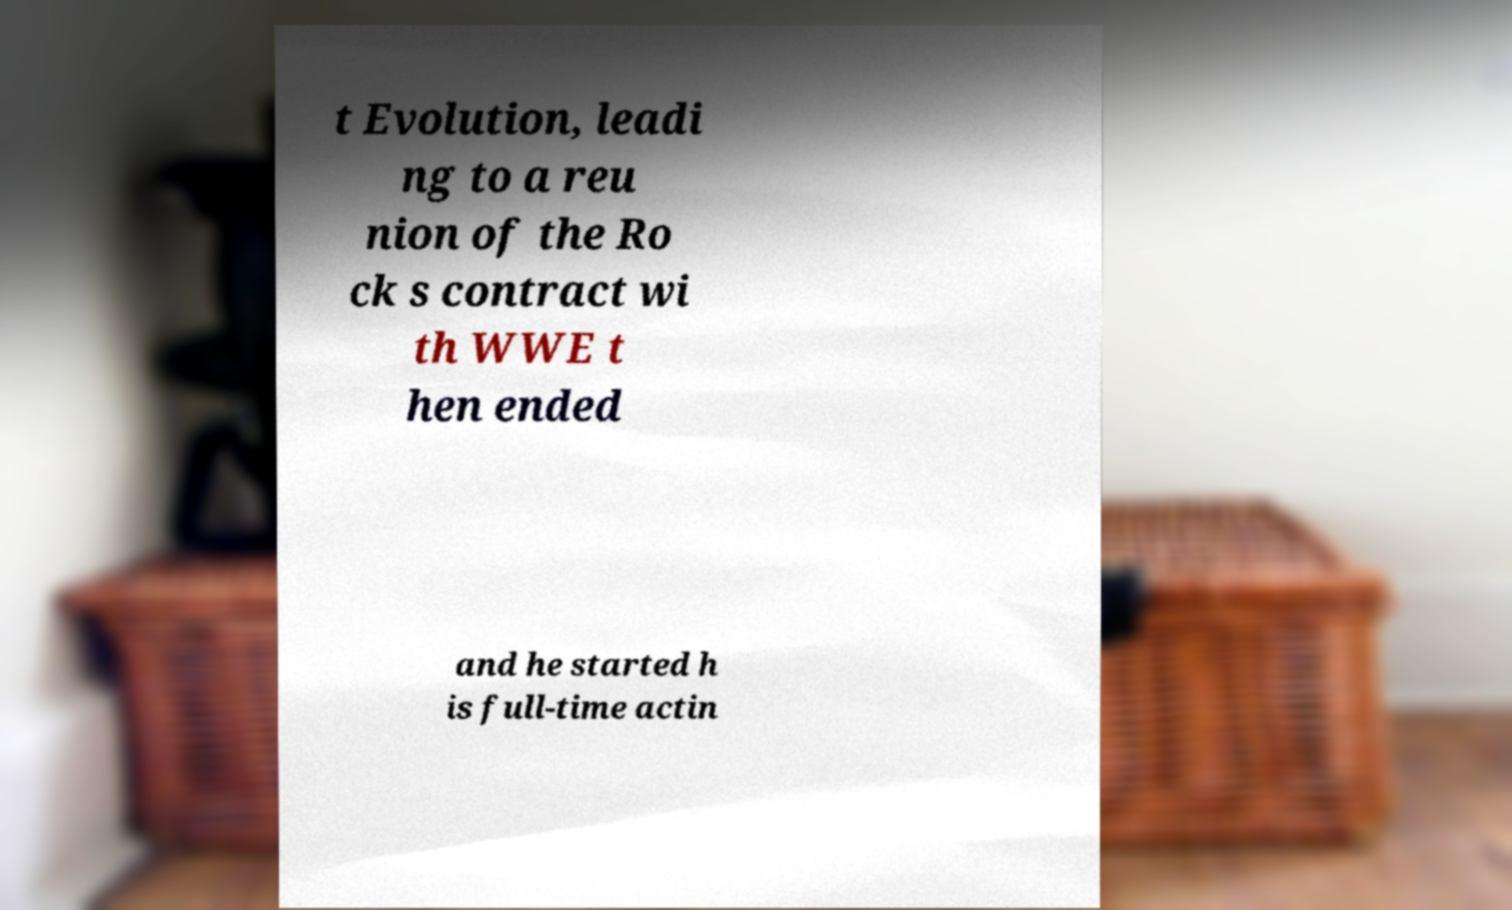Could you extract and type out the text from this image? t Evolution, leadi ng to a reu nion of the Ro ck s contract wi th WWE t hen ended and he started h is full-time actin 